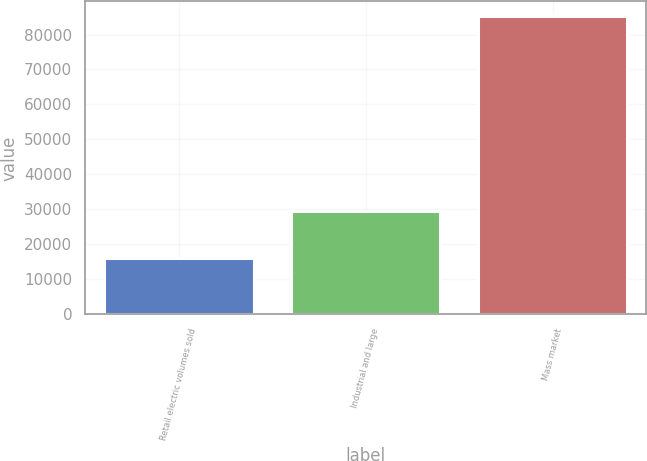Convert chart to OTSL. <chart><loc_0><loc_0><loc_500><loc_500><bar_chart><fcel>Retail electric volumes sold<fcel>Industrial and large<fcel>Mass market<nl><fcel>15993<fcel>29561<fcel>85191<nl></chart> 